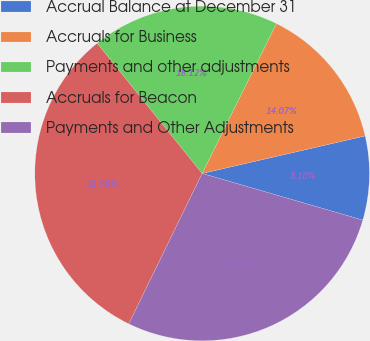Convert chart to OTSL. <chart><loc_0><loc_0><loc_500><loc_500><pie_chart><fcel>Accrual Balance at December 31<fcel>Accruals for Business<fcel>Payments and other adjustments<fcel>Accruals for Beacon<fcel>Payments and Other Adjustments<nl><fcel>8.1%<fcel>14.07%<fcel>18.12%<fcel>31.98%<fcel>27.72%<nl></chart> 